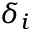Convert formula to latex. <formula><loc_0><loc_0><loc_500><loc_500>\delta _ { i }</formula> 